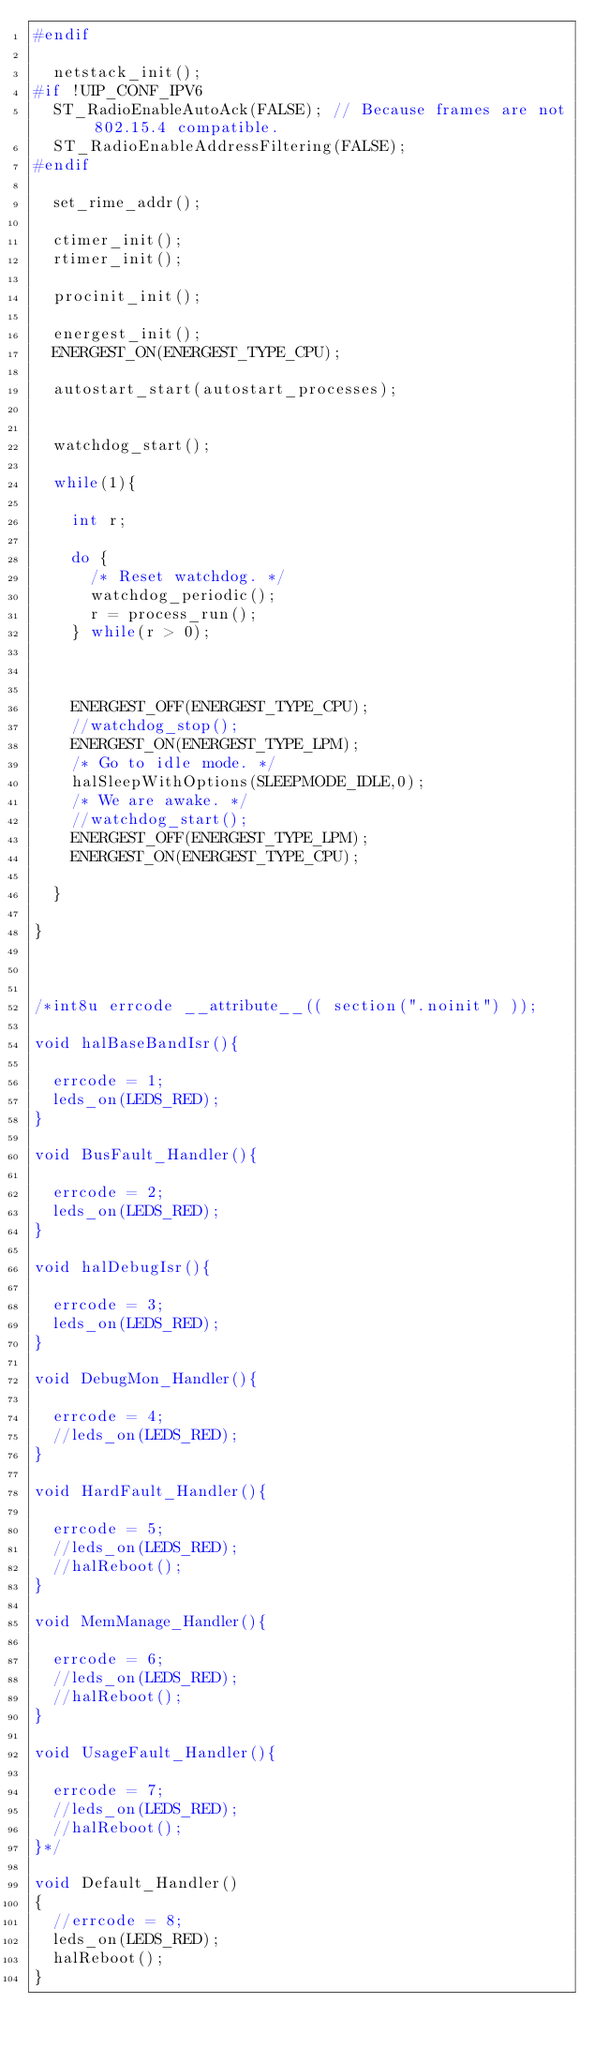Convert code to text. <code><loc_0><loc_0><loc_500><loc_500><_C_>#endif
  
  netstack_init();
#if !UIP_CONF_IPV6
  ST_RadioEnableAutoAck(FALSE); // Because frames are not 802.15.4 compatible. 
  ST_RadioEnableAddressFiltering(FALSE);
#endif

  set_rime_addr();
  
  ctimer_init();
  rtimer_init();
  
  procinit_init();    

  energest_init();
  ENERGEST_ON(ENERGEST_TYPE_CPU);
  
  autostart_start(autostart_processes);
  
  
  watchdog_start();
  
  while(1){
    
    int r;    
    
    do {
      /* Reset watchdog. */
      watchdog_periodic();
      r = process_run();
    } while(r > 0);
    
    
    
    ENERGEST_OFF(ENERGEST_TYPE_CPU);
    //watchdog_stop();    
    ENERGEST_ON(ENERGEST_TYPE_LPM);
    /* Go to idle mode. */
    halSleepWithOptions(SLEEPMODE_IDLE,0);
    /* We are awake. */
    //watchdog_start();
    ENERGEST_OFF(ENERGEST_TYPE_LPM);
    ENERGEST_ON(ENERGEST_TYPE_CPU);  
    
  }
  
}



/*int8u errcode __attribute__(( section(".noinit") ));

void halBaseBandIsr(){
  
  errcode = 1;
  leds_on(LEDS_RED);
}

void BusFault_Handler(){
  
  errcode = 2; 
  leds_on(LEDS_RED);
}

void halDebugIsr(){
  
  errcode = 3;
  leds_on(LEDS_RED);  
}

void DebugMon_Handler(){
  
  errcode = 4;
  //leds_on(LEDS_RED);  
}

void HardFault_Handler(){
  
  errcode = 5; 
  //leds_on(LEDS_RED);
  //halReboot();
}

void MemManage_Handler(){
  
  errcode = 6; 
  //leds_on(LEDS_RED);
  //halReboot();
}

void UsageFault_Handler(){
  
  errcode = 7; 
  //leds_on(LEDS_RED);
  //halReboot();
}*/

void Default_Handler() 
{ 
  //errcode = 8; 
  leds_on(LEDS_RED);
  halReboot();
}
</code> 